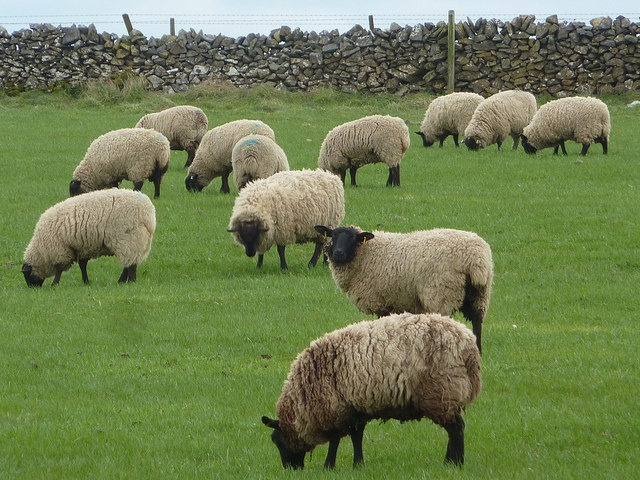Describe the objects in this image and their specific colors. I can see sheep in lightblue, black, darkgreen, and gray tones, sheep in lightblue, gray, black, and darkgreen tones, sheep in lightblue, gray, tan, and black tones, sheep in lightblue, gray, black, and tan tones, and sheep in lightblue, gray, tan, and black tones in this image. 